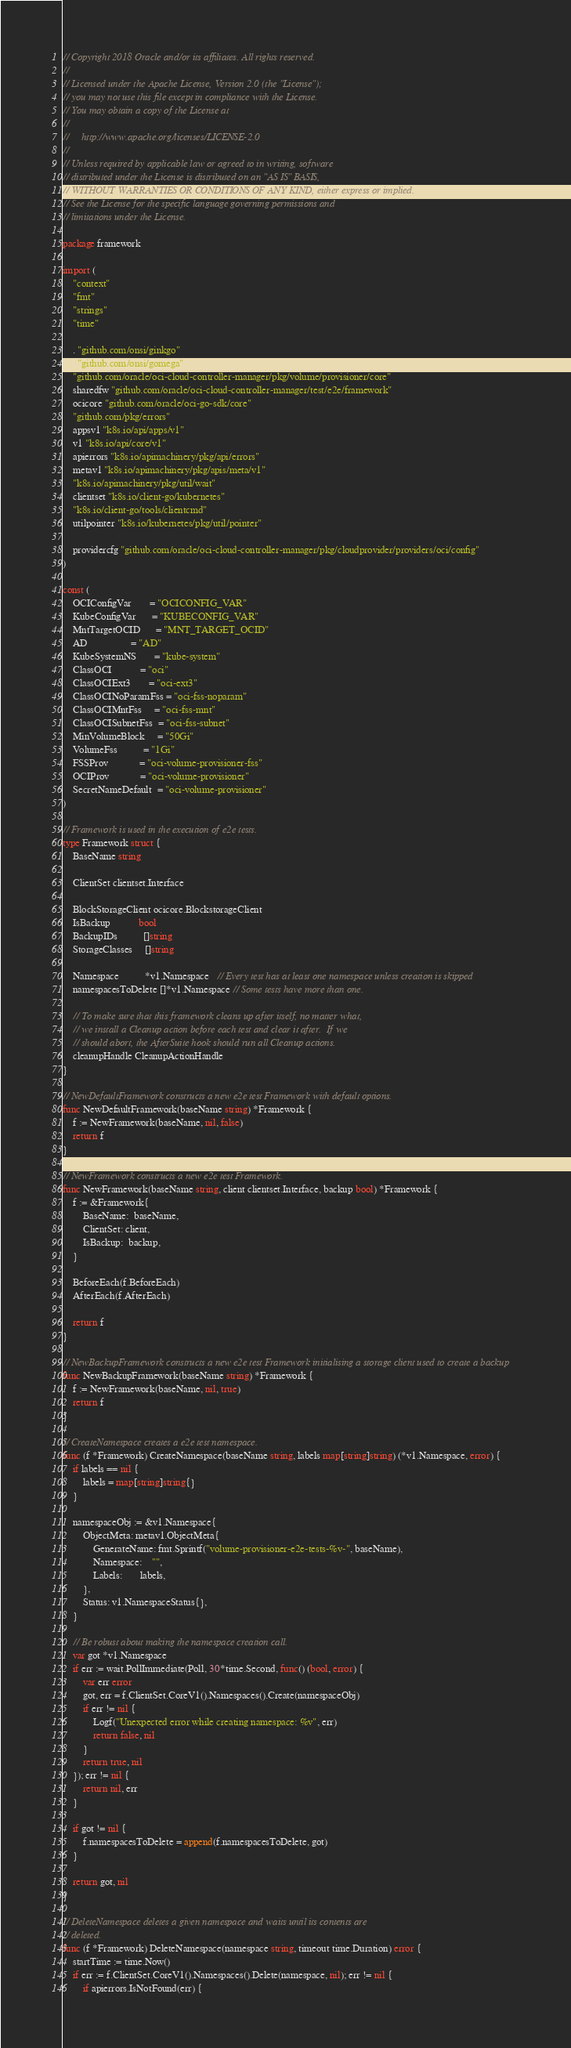<code> <loc_0><loc_0><loc_500><loc_500><_Go_>// Copyright 2018 Oracle and/or its affiliates. All rights reserved.
//
// Licensed under the Apache License, Version 2.0 (the "License");
// you may not use this file except in compliance with the License.
// You may obtain a copy of the License at
//
//     http://www.apache.org/licenses/LICENSE-2.0
//
// Unless required by applicable law or agreed to in writing, software
// distributed under the License is distributed on an "AS IS" BASIS,
// WITHOUT WARRANTIES OR CONDITIONS OF ANY KIND, either express or implied.
// See the License for the specific language governing permissions and
// limitations under the License.

package framework

import (
	"context"
	"fmt"
	"strings"
	"time"

	. "github.com/onsi/ginkgo"
	. "github.com/onsi/gomega"
	"github.com/oracle/oci-cloud-controller-manager/pkg/volume/provisioner/core"
	sharedfw "github.com/oracle/oci-cloud-controller-manager/test/e2e/framework"
	ocicore "github.com/oracle/oci-go-sdk/core"
	"github.com/pkg/errors"
	appsv1 "k8s.io/api/apps/v1"
	v1 "k8s.io/api/core/v1"
	apierrors "k8s.io/apimachinery/pkg/api/errors"
	metav1 "k8s.io/apimachinery/pkg/apis/meta/v1"
	"k8s.io/apimachinery/pkg/util/wait"
	clientset "k8s.io/client-go/kubernetes"
	"k8s.io/client-go/tools/clientcmd"
	utilpointer "k8s.io/kubernetes/pkg/util/pointer"

	providercfg "github.com/oracle/oci-cloud-controller-manager/pkg/cloudprovider/providers/oci/config"
)

const (
	OCIConfigVar       = "OCICONFIG_VAR"
	KubeConfigVar      = "KUBECONFIG_VAR"
	MntTargetOCID      = "MNT_TARGET_OCID"
	AD                 = "AD"
	KubeSystemNS       = "kube-system"
	ClassOCI           = "oci"
	ClassOCIExt3       = "oci-ext3"
	ClassOCINoParamFss = "oci-fss-noparam"
	ClassOCIMntFss     = "oci-fss-mnt"
	ClassOCISubnetFss  = "oci-fss-subnet"
	MinVolumeBlock     = "50Gi"
	VolumeFss          = "1Gi"
	FSSProv            = "oci-volume-provisioner-fss"
	OCIProv            = "oci-volume-provisioner"
	SecretNameDefault  = "oci-volume-provisioner"
)

// Framework is used in the execution of e2e tests.
type Framework struct {
	BaseName string

	ClientSet clientset.Interface

	BlockStorageClient ocicore.BlockstorageClient
	IsBackup           bool
	BackupIDs          []string
	StorageClasses     []string

	Namespace          *v1.Namespace   // Every test has at least one namespace unless creation is skipped
	namespacesToDelete []*v1.Namespace // Some tests have more than one.

	// To make sure that this framework cleans up after itself, no matter what,
	// we install a Cleanup action before each test and clear it after.  If we
	// should abort, the AfterSuite hook should run all Cleanup actions.
	cleanupHandle CleanupActionHandle
}

// NewDefaultFramework constructs a new e2e test Framework with default options.
func NewDefaultFramework(baseName string) *Framework {
	f := NewFramework(baseName, nil, false)
	return f
}

// NewFramework constructs a new e2e test Framework.
func NewFramework(baseName string, client clientset.Interface, backup bool) *Framework {
	f := &Framework{
		BaseName:  baseName,
		ClientSet: client,
		IsBackup:  backup,
	}

	BeforeEach(f.BeforeEach)
	AfterEach(f.AfterEach)

	return f
}

// NewBackupFramework constructs a new e2e test Framework initialising a storage client used to create a backup
func NewBackupFramework(baseName string) *Framework {
	f := NewFramework(baseName, nil, true)
	return f
}

// CreateNamespace creates a e2e test namespace.
func (f *Framework) CreateNamespace(baseName string, labels map[string]string) (*v1.Namespace, error) {
	if labels == nil {
		labels = map[string]string{}
	}

	namespaceObj := &v1.Namespace{
		ObjectMeta: metav1.ObjectMeta{
			GenerateName: fmt.Sprintf("volume-provisioner-e2e-tests-%v-", baseName),
			Namespace:    "",
			Labels:       labels,
		},
		Status: v1.NamespaceStatus{},
	}

	// Be robust about making the namespace creation call.
	var got *v1.Namespace
	if err := wait.PollImmediate(Poll, 30*time.Second, func() (bool, error) {
		var err error
		got, err = f.ClientSet.CoreV1().Namespaces().Create(namespaceObj)
		if err != nil {
			Logf("Unexpected error while creating namespace: %v", err)
			return false, nil
		}
		return true, nil
	}); err != nil {
		return nil, err
	}

	if got != nil {
		f.namespacesToDelete = append(f.namespacesToDelete, got)
	}

	return got, nil
}

// DeleteNamespace deletes a given namespace and waits until its contents are
// deleted.
func (f *Framework) DeleteNamespace(namespace string, timeout time.Duration) error {
	startTime := time.Now()
	if err := f.ClientSet.CoreV1().Namespaces().Delete(namespace, nil); err != nil {
		if apierrors.IsNotFound(err) {</code> 